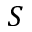<formula> <loc_0><loc_0><loc_500><loc_500>S</formula> 